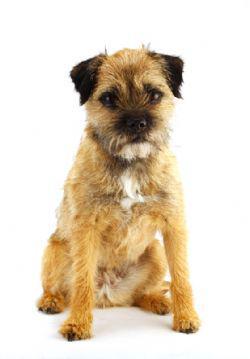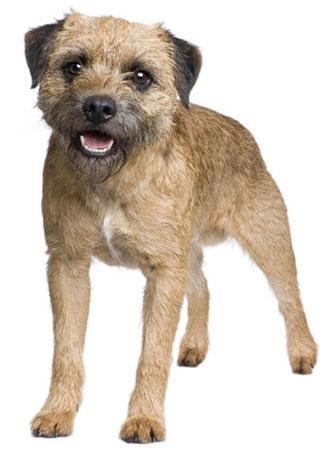The first image is the image on the left, the second image is the image on the right. Examine the images to the left and right. Is the description "On the right, the dog's body is turned to the left." accurate? Answer yes or no. Yes. The first image is the image on the left, the second image is the image on the right. Evaluate the accuracy of this statement regarding the images: "there is no visible grass". Is it true? Answer yes or no. Yes. 